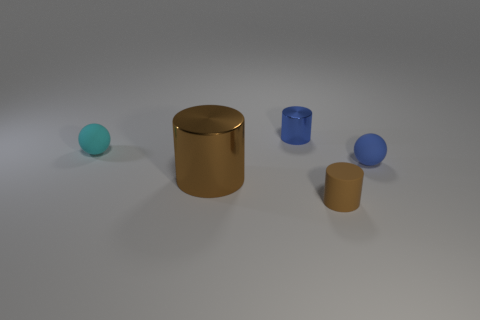Add 3 metal cylinders. How many objects exist? 8 Subtract 1 balls. How many balls are left? 1 Subtract all small rubber cylinders. How many cylinders are left? 2 Subtract 0 blue blocks. How many objects are left? 5 Subtract all cylinders. How many objects are left? 2 Subtract all cyan cylinders. Subtract all cyan blocks. How many cylinders are left? 3 Subtract all red blocks. How many brown balls are left? 0 Subtract all small rubber cubes. Subtract all blue balls. How many objects are left? 4 Add 2 tiny spheres. How many tiny spheres are left? 4 Add 3 small matte cylinders. How many small matte cylinders exist? 4 